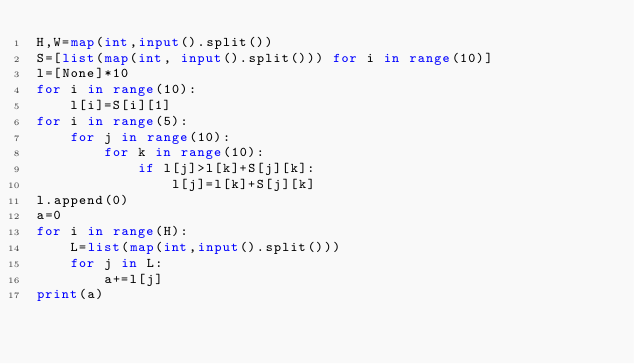Convert code to text. <code><loc_0><loc_0><loc_500><loc_500><_Python_>H,W=map(int,input().split())
S=[list(map(int, input().split())) for i in range(10)]
l=[None]*10
for i in range(10):
    l[i]=S[i][1]
for i in range(5):
    for j in range(10):
        for k in range(10):
            if l[j]>l[k]+S[j][k]:
                l[j]=l[k]+S[j][k]
l.append(0)
a=0
for i in range(H):
    L=list(map(int,input().split()))
    for j in L:
        a+=l[j]
print(a)</code> 